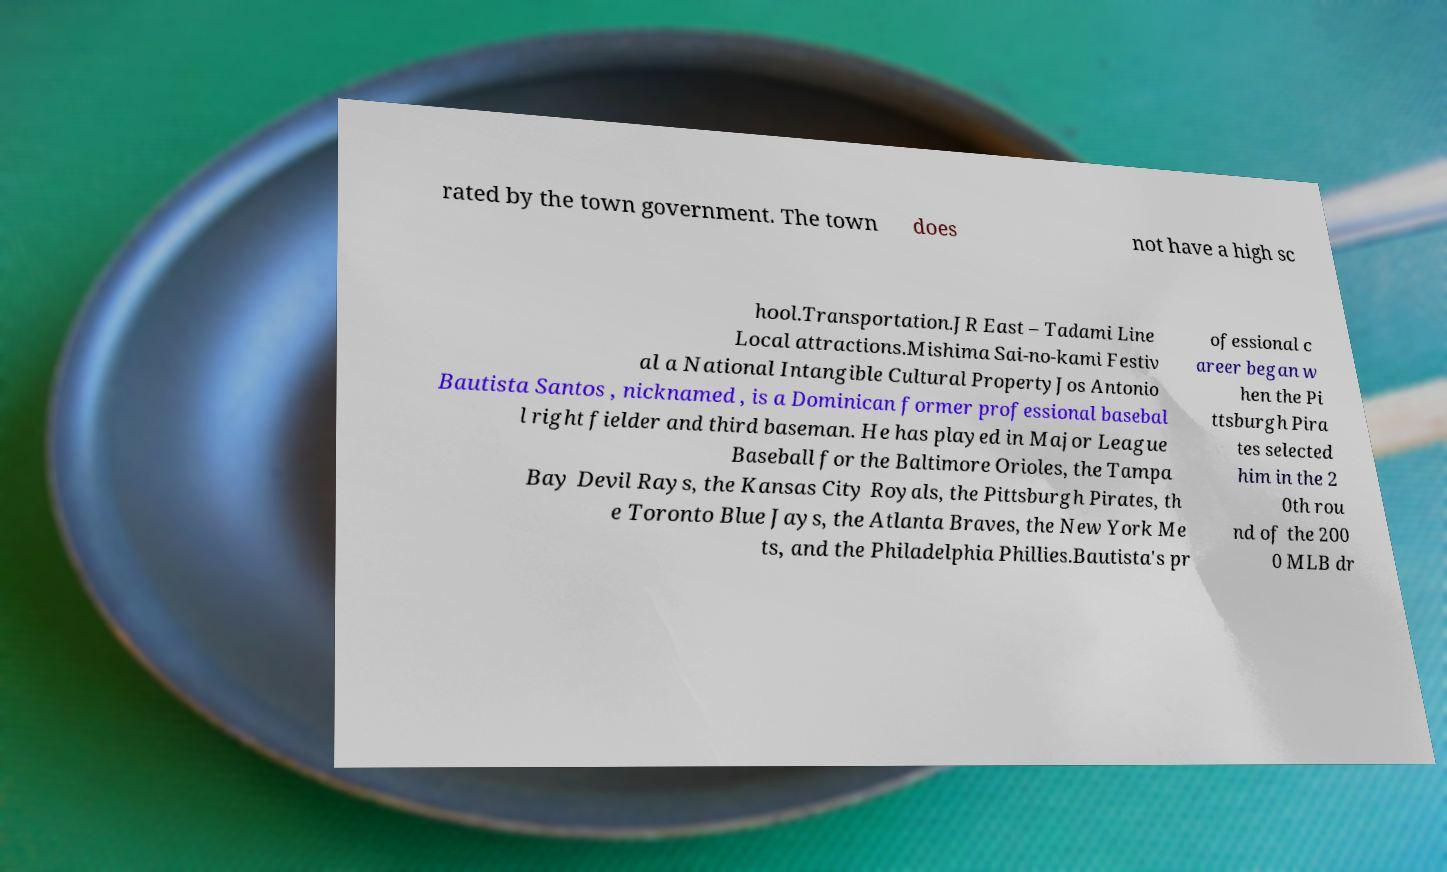There's text embedded in this image that I need extracted. Can you transcribe it verbatim? rated by the town government. The town does not have a high sc hool.Transportation.JR East – Tadami Line Local attractions.Mishima Sai-no-kami Festiv al a National Intangible Cultural PropertyJos Antonio Bautista Santos , nicknamed , is a Dominican former professional basebal l right fielder and third baseman. He has played in Major League Baseball for the Baltimore Orioles, the Tampa Bay Devil Rays, the Kansas City Royals, the Pittsburgh Pirates, th e Toronto Blue Jays, the Atlanta Braves, the New York Me ts, and the Philadelphia Phillies.Bautista's pr ofessional c areer began w hen the Pi ttsburgh Pira tes selected him in the 2 0th rou nd of the 200 0 MLB dr 